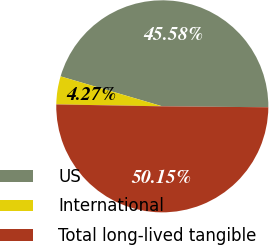Convert chart. <chart><loc_0><loc_0><loc_500><loc_500><pie_chart><fcel>US<fcel>International<fcel>Total long-lived tangible<nl><fcel>45.58%<fcel>4.27%<fcel>50.14%<nl></chart> 